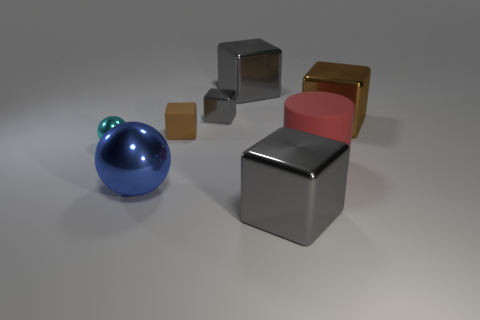How many other things are the same color as the small matte cube?
Keep it short and to the point. 1. What number of red things are either metallic objects or small matte blocks?
Provide a short and direct response. 0. Does the large gray object that is in front of the blue metal thing have the same shape as the rubber thing that is in front of the small cyan thing?
Give a very brief answer. No. How many other objects are the same material as the large sphere?
Keep it short and to the point. 5. Are there any tiny gray metal cubes left of the metallic ball on the right side of the tiny thing in front of the tiny matte cube?
Give a very brief answer. No. Does the tiny brown object have the same material as the small cyan ball?
Provide a succinct answer. No. Is there any other thing that has the same shape as the small gray object?
Your answer should be very brief. Yes. What material is the big gray block behind the sphere that is left of the big blue object made of?
Provide a short and direct response. Metal. There is a gray object in front of the large brown thing; what is its size?
Your response must be concise. Large. What is the color of the big metal cube that is both left of the big brown metallic cube and behind the small rubber thing?
Provide a short and direct response. Gray. 